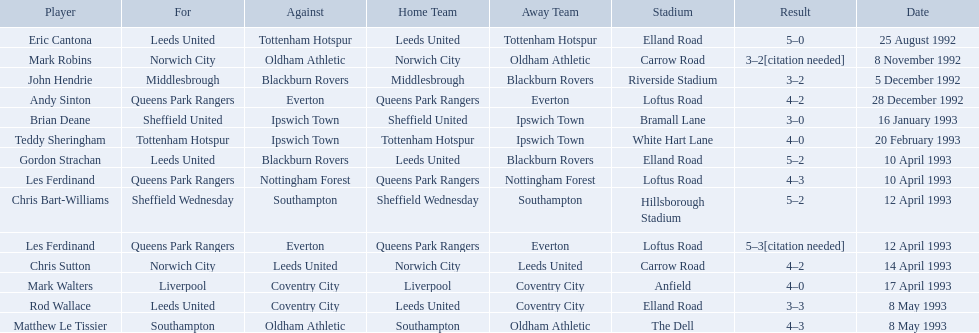What are the results? 5–0, 3–2[citation needed], 3–2, 4–2, 3–0, 4–0, 5–2, 4–3, 5–2, 5–3[citation needed], 4–2, 4–0, 3–3, 4–3. What result did mark robins have? 3–2[citation needed]. What other player had that result? John Hendrie. 